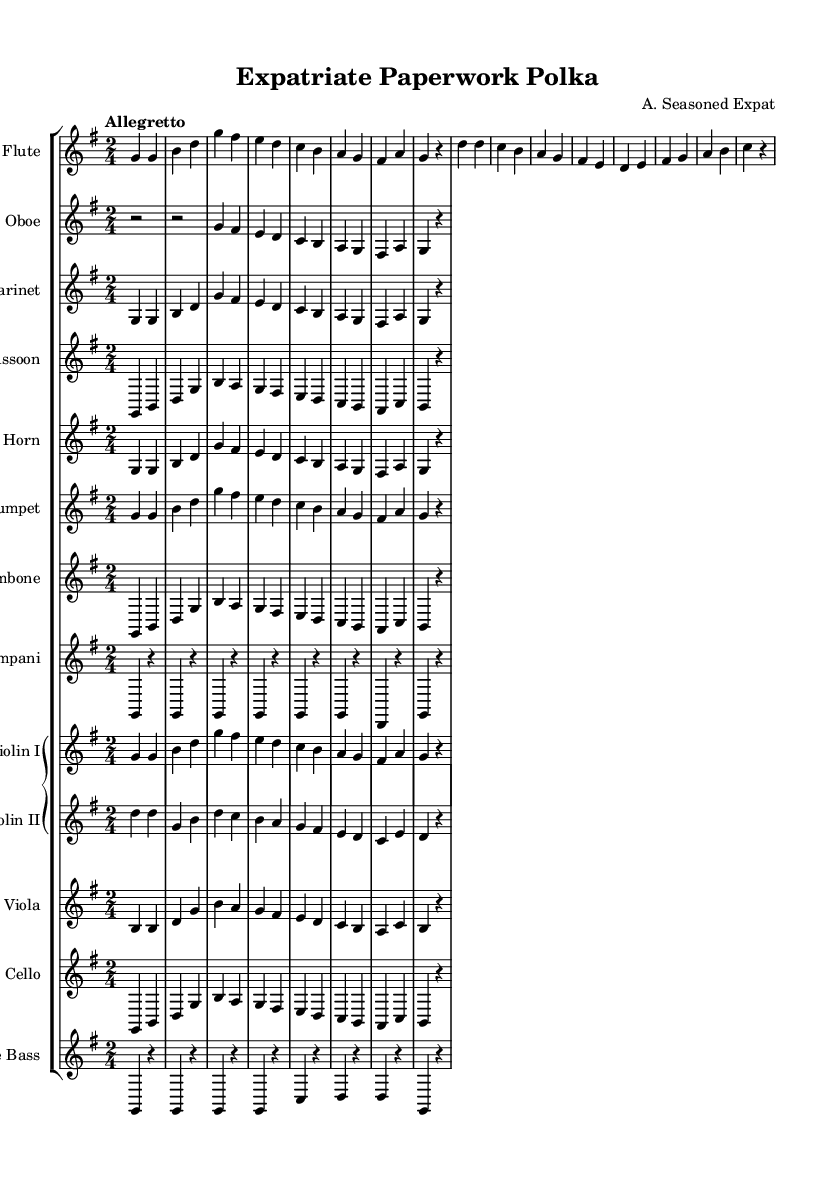What is the key signature of this symphony? The key signature is G major, which includes one sharp (F#). This is indicated at the beginning of the staff with the sharp sign placed on the F line in the treble clef.
Answer: G major What is the time signature of this piece? The time signature is 2/4, as shown at the beginning of the score. This means there are two beats in each measure and a quarter note receives one beat.
Answer: 2/4 What is the tempo marking for this symphony? The tempo marking is "Allegretto," which indicates a moderately fast tempo. This is usually understood as being slightly slower than "Allegro."
Answer: Allegretto Which instrument has the first entry in the music? The Flute has the first entry, as it begins the first measure with a G note. This makes it the initial voice in the orchestration.
Answer: Flute How many different woodwind instruments are used in this symphony? There are five woodwind instruments: Flute, Oboe, Clarinet, Bassoon, and Horn. They contribute to creating a rich tapestry of sound throughout the piece.
Answer: Five What is the rhythmic pattern established in the flute melody? The rhythmic pattern primarily consists of quarter notes and rests, giving a bouncy feel to the melody. For example, the opening consists of two G quarter notes followed by a quarter note rest, resulting in a light and playful rhythm.
Answer: Quarter notes and rests Which string instrument plays a different rhythmic pattern from the others? The Double Bass plays a sustained rhythmic pattern, primarily using whole notes with rests. This contrasts with the more active rhythmic patterns present in the higher string instruments and the woodwinds.
Answer: Double Bass 